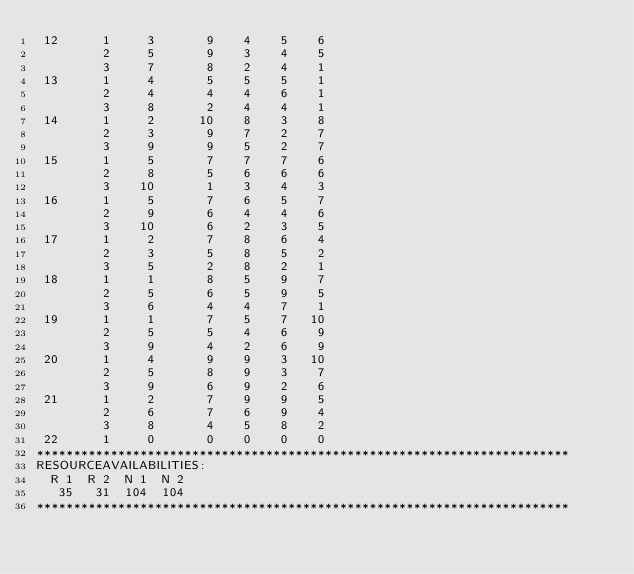Convert code to text. <code><loc_0><loc_0><loc_500><loc_500><_ObjectiveC_> 12      1     3       9    4    5    6
         2     5       9    3    4    5
         3     7       8    2    4    1
 13      1     4       5    5    5    1
         2     4       4    4    6    1
         3     8       2    4    4    1
 14      1     2      10    8    3    8
         2     3       9    7    2    7
         3     9       9    5    2    7
 15      1     5       7    7    7    6
         2     8       5    6    6    6
         3    10       1    3    4    3
 16      1     5       7    6    5    7
         2     9       6    4    4    6
         3    10       6    2    3    5
 17      1     2       7    8    6    4
         2     3       5    8    5    2
         3     5       2    8    2    1
 18      1     1       8    5    9    7
         2     5       6    5    9    5
         3     6       4    4    7    1
 19      1     1       7    5    7   10
         2     5       5    4    6    9
         3     9       4    2    6    9
 20      1     4       9    9    3   10
         2     5       8    9    3    7
         3     9       6    9    2    6
 21      1     2       7    9    9    5
         2     6       7    6    9    4
         3     8       4    5    8    2
 22      1     0       0    0    0    0
************************************************************************
RESOURCEAVAILABILITIES:
  R 1  R 2  N 1  N 2
   35   31  104  104
************************************************************************
</code> 